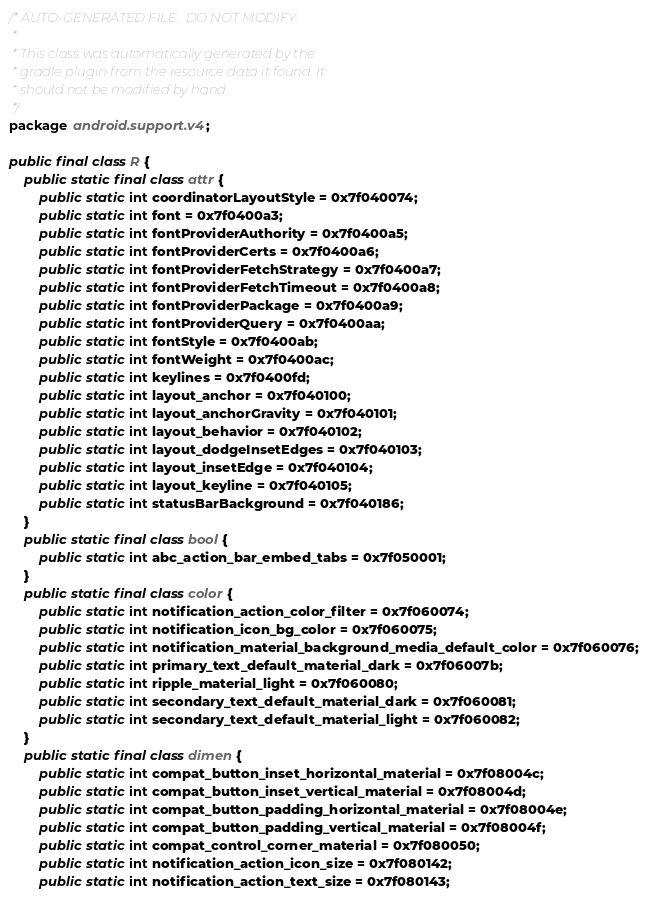Convert code to text. <code><loc_0><loc_0><loc_500><loc_500><_Java_>/* AUTO-GENERATED FILE.  DO NOT MODIFY.
 *
 * This class was automatically generated by the
 * gradle plugin from the resource data it found. It
 * should not be modified by hand.
 */
package android.support.v4;

public final class R {
    public static final class attr {
        public static int coordinatorLayoutStyle = 0x7f040074;
        public static int font = 0x7f0400a3;
        public static int fontProviderAuthority = 0x7f0400a5;
        public static int fontProviderCerts = 0x7f0400a6;
        public static int fontProviderFetchStrategy = 0x7f0400a7;
        public static int fontProviderFetchTimeout = 0x7f0400a8;
        public static int fontProviderPackage = 0x7f0400a9;
        public static int fontProviderQuery = 0x7f0400aa;
        public static int fontStyle = 0x7f0400ab;
        public static int fontWeight = 0x7f0400ac;
        public static int keylines = 0x7f0400fd;
        public static int layout_anchor = 0x7f040100;
        public static int layout_anchorGravity = 0x7f040101;
        public static int layout_behavior = 0x7f040102;
        public static int layout_dodgeInsetEdges = 0x7f040103;
        public static int layout_insetEdge = 0x7f040104;
        public static int layout_keyline = 0x7f040105;
        public static int statusBarBackground = 0x7f040186;
    }
    public static final class bool {
        public static int abc_action_bar_embed_tabs = 0x7f050001;
    }
    public static final class color {
        public static int notification_action_color_filter = 0x7f060074;
        public static int notification_icon_bg_color = 0x7f060075;
        public static int notification_material_background_media_default_color = 0x7f060076;
        public static int primary_text_default_material_dark = 0x7f06007b;
        public static int ripple_material_light = 0x7f060080;
        public static int secondary_text_default_material_dark = 0x7f060081;
        public static int secondary_text_default_material_light = 0x7f060082;
    }
    public static final class dimen {
        public static int compat_button_inset_horizontal_material = 0x7f08004c;
        public static int compat_button_inset_vertical_material = 0x7f08004d;
        public static int compat_button_padding_horizontal_material = 0x7f08004e;
        public static int compat_button_padding_vertical_material = 0x7f08004f;
        public static int compat_control_corner_material = 0x7f080050;
        public static int notification_action_icon_size = 0x7f080142;
        public static int notification_action_text_size = 0x7f080143;</code> 